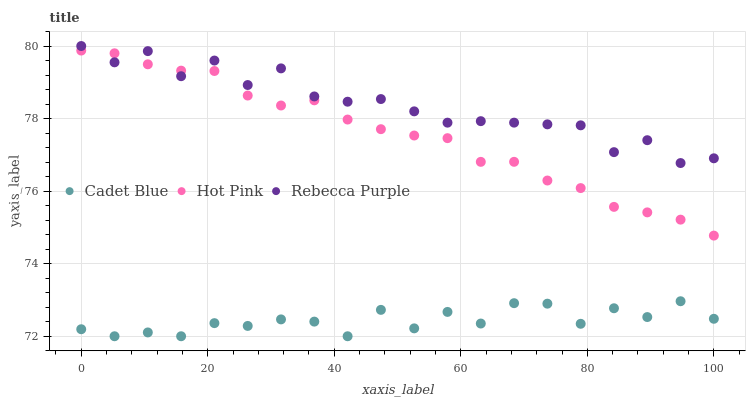Does Cadet Blue have the minimum area under the curve?
Answer yes or no. Yes. Does Rebecca Purple have the maximum area under the curve?
Answer yes or no. Yes. Does Hot Pink have the minimum area under the curve?
Answer yes or no. No. Does Hot Pink have the maximum area under the curve?
Answer yes or no. No. Is Hot Pink the smoothest?
Answer yes or no. Yes. Is Cadet Blue the roughest?
Answer yes or no. Yes. Is Rebecca Purple the smoothest?
Answer yes or no. No. Is Rebecca Purple the roughest?
Answer yes or no. No. Does Cadet Blue have the lowest value?
Answer yes or no. Yes. Does Hot Pink have the lowest value?
Answer yes or no. No. Does Rebecca Purple have the highest value?
Answer yes or no. Yes. Does Hot Pink have the highest value?
Answer yes or no. No. Is Cadet Blue less than Hot Pink?
Answer yes or no. Yes. Is Rebecca Purple greater than Cadet Blue?
Answer yes or no. Yes. Does Hot Pink intersect Rebecca Purple?
Answer yes or no. Yes. Is Hot Pink less than Rebecca Purple?
Answer yes or no. No. Is Hot Pink greater than Rebecca Purple?
Answer yes or no. No. Does Cadet Blue intersect Hot Pink?
Answer yes or no. No. 